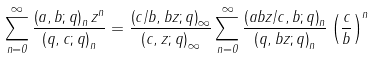<formula> <loc_0><loc_0><loc_500><loc_500>\sum _ { n = 0 } ^ { \infty } \frac { \left ( a , b ; q \right ) _ { n } z ^ { n } } { \left ( q , c ; q \right ) _ { n } } = \frac { \left ( c / b , b z ; q \right ) _ { \infty } } { \left ( c , z ; q \right ) _ { \infty } } \sum _ { n = 0 } ^ { \infty } \frac { \left ( a b z / c , b ; q \right ) _ { n } } { \left ( q , b z ; q \right ) _ { n } } \left ( \frac { c } { b } \right ) ^ { n }</formula> 